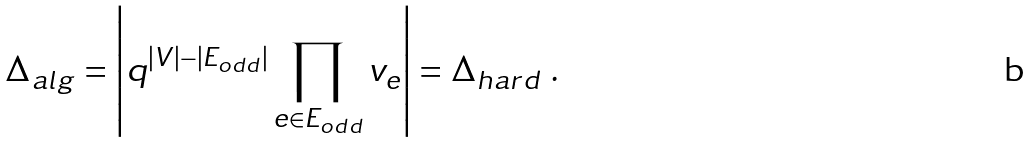Convert formula to latex. <formula><loc_0><loc_0><loc_500><loc_500>\Delta _ { a l g } = \left | q ^ { | V | - | E _ { o d d } | } \prod _ { e \in E _ { o d d } } v _ { e } \right | = \Delta _ { h a r d } \ .</formula> 